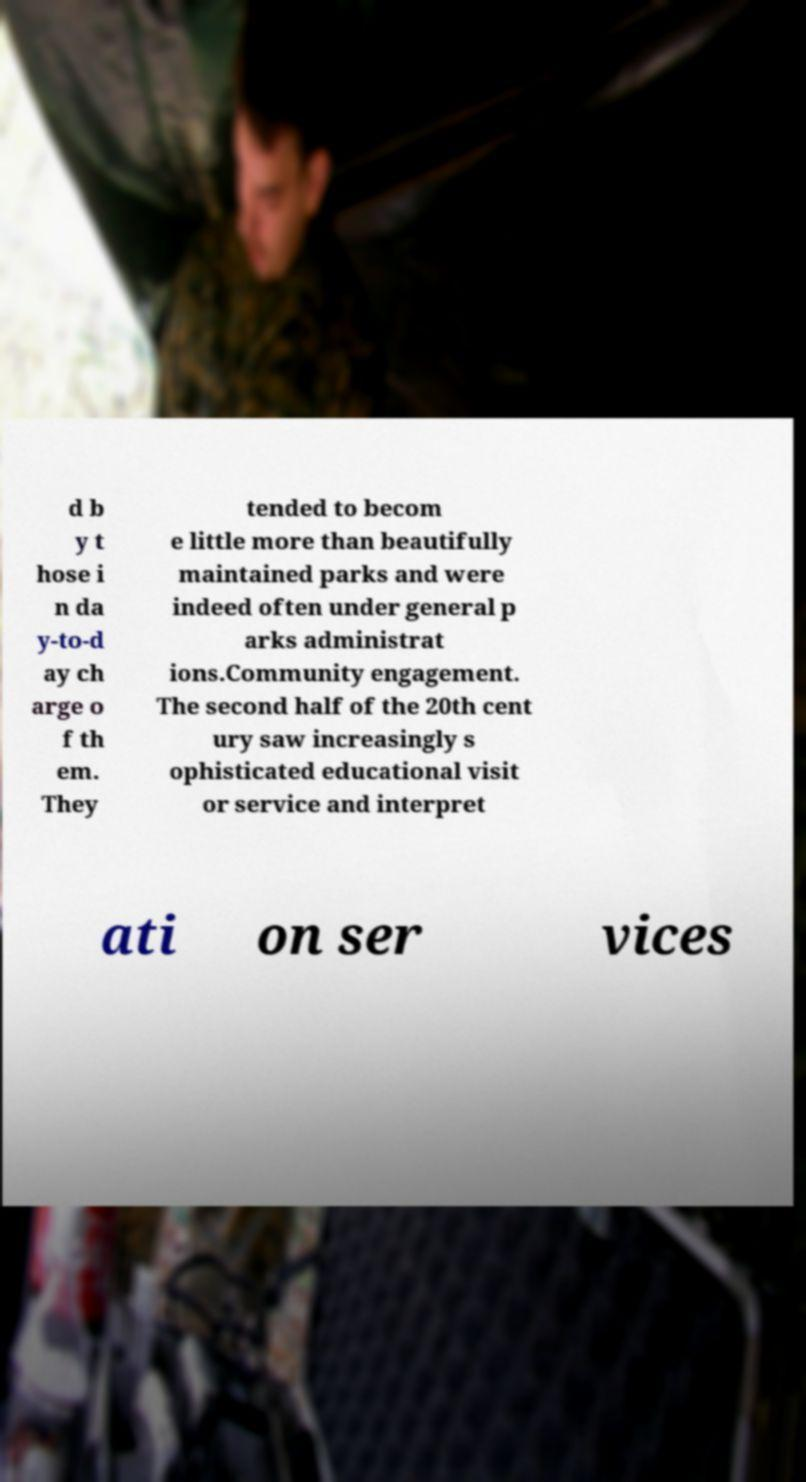Can you accurately transcribe the text from the provided image for me? d b y t hose i n da y-to-d ay ch arge o f th em. They tended to becom e little more than beautifully maintained parks and were indeed often under general p arks administrat ions.Community engagement. The second half of the 20th cent ury saw increasingly s ophisticated educational visit or service and interpret ati on ser vices 